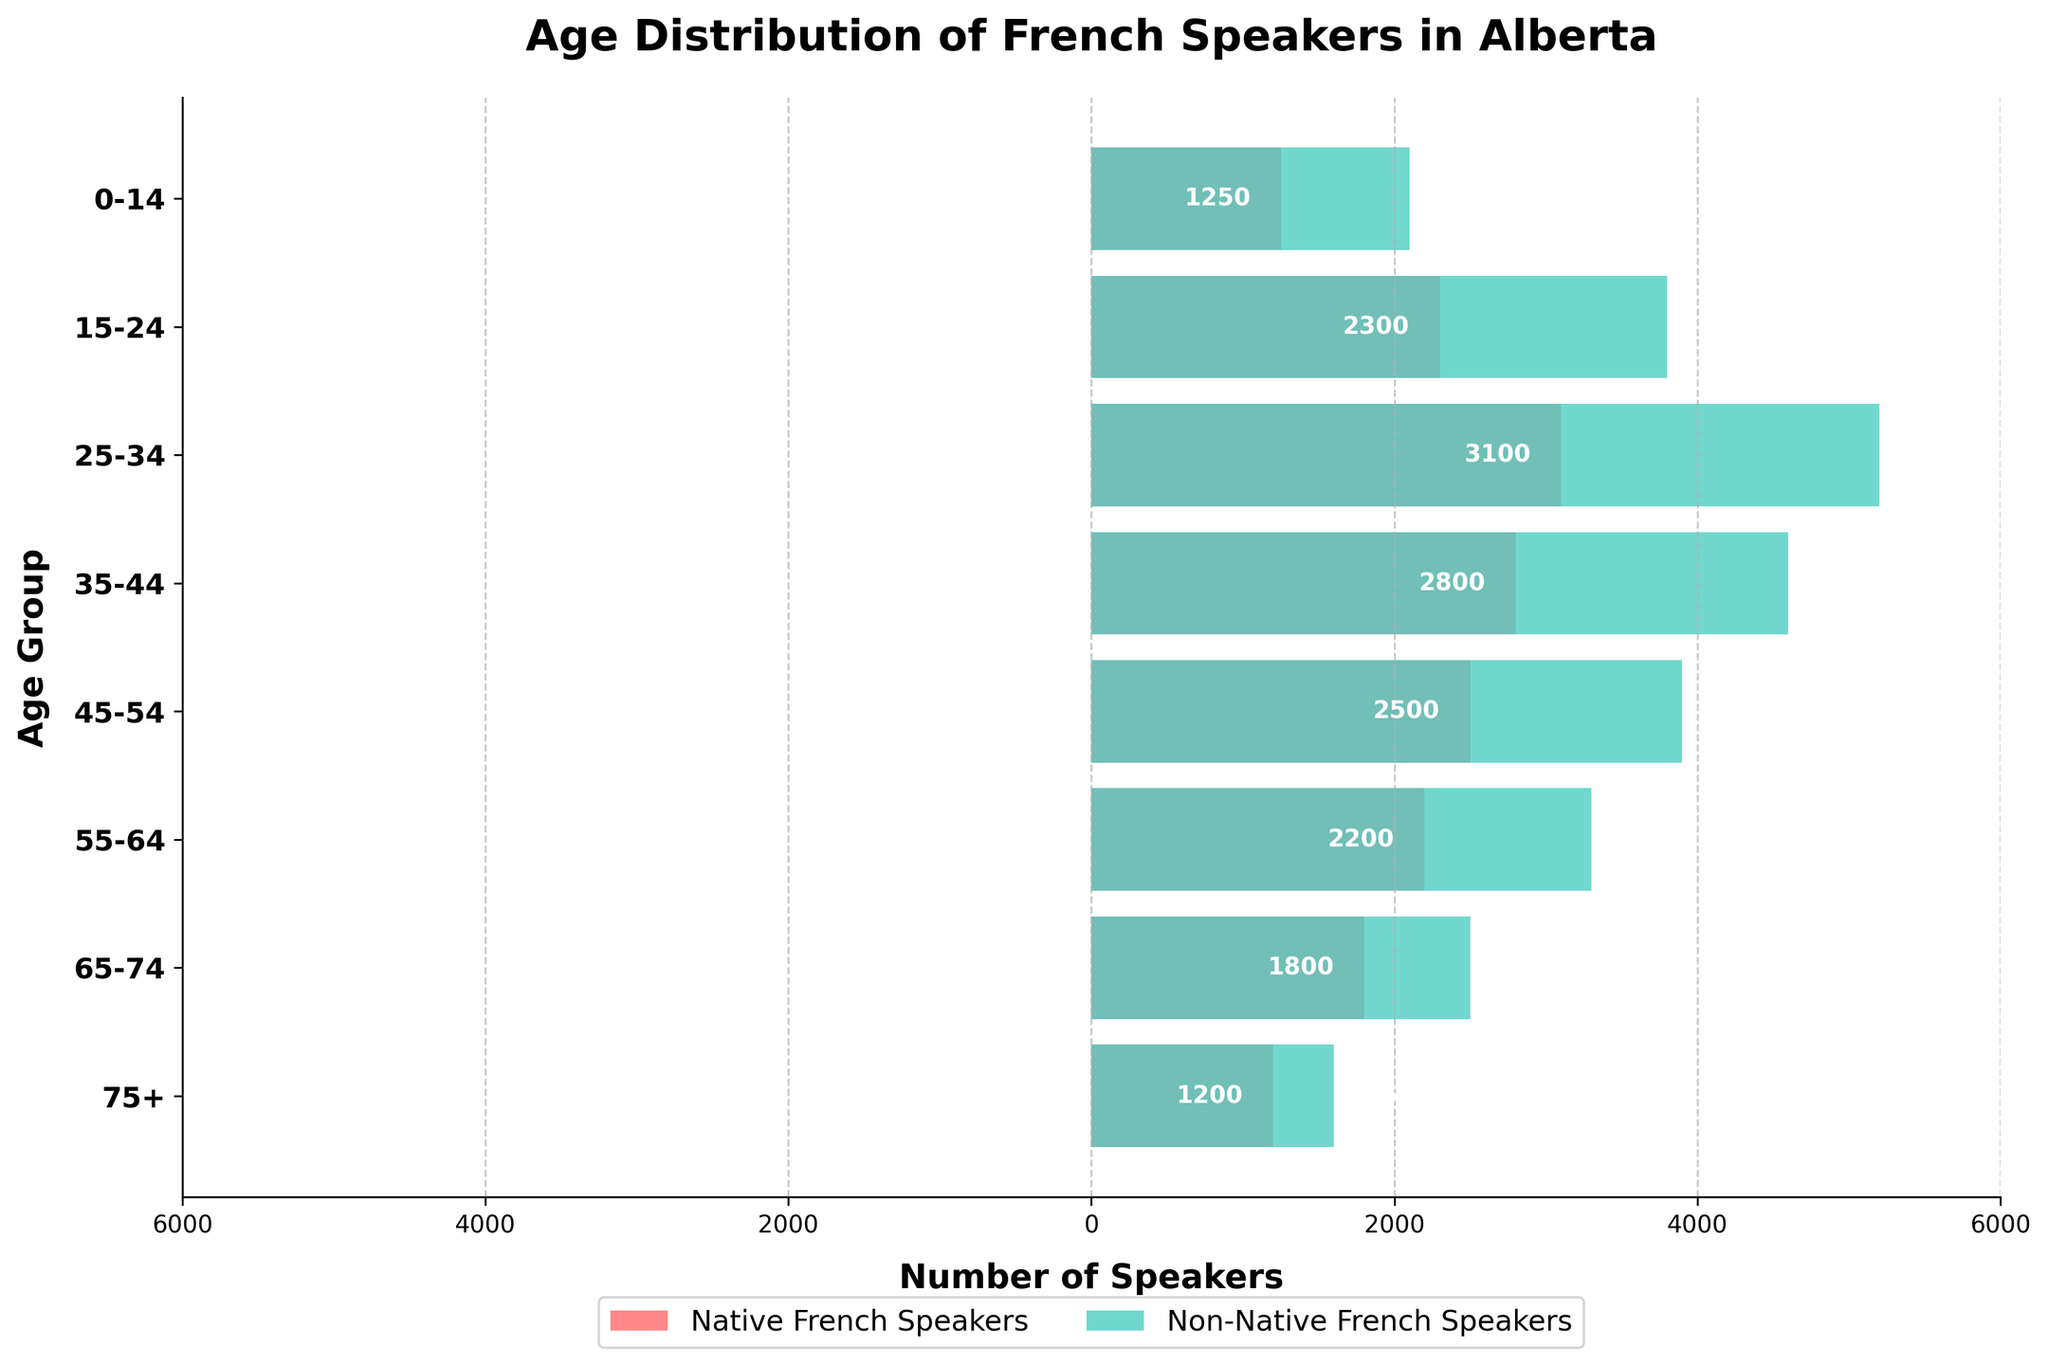What's the title of the figure? The title is displayed at the top of the figure, making it easy to identify without any deeper interpretation or analysis.
Answer: Age Distribution of French Speakers in Alberta Which age group has the highest number of non-native French speakers? The highest bar on the non-native French speakers' side represents the largest number, and it corresponds to the 25-34 age group.
Answer: 25-34 How many native French speakers are aged 0-14? Look at the value corresponding to the 0-14 age group on the native French speakers' side. The number (ignoring the negative sign) on that bar is 1250.
Answer: 1250 Compare the number of native and non-native French speakers aged 35-44. Which group has more speakers and by how many? The bar for native French speakers aged 35-44 indicates 2800, and the bar for non-native French speakers indicates 4600. Subtract the number of native speakers from non-native speakers: 4600 - 2800 = 1800.
Answer: Non-native by 1800 Consider the age group 55-64. What is the ratio of non-native French speakers to native French speakers? The number of non-native speakers in this group is 3300 and native speakers are 2200. The ratio is calculated as 3300 / 2200.
Answer: 1.5 Which age group has the smallest difference in the number of native and non-native French speakers, and what is that difference? Calculate the absolute difference for each age group and find the smallest. For example, 1200-2100, 2300-3800, etc. The smallest difference seems to be in the 75+ age group: 1600 - 1200 = 400.
Answer: 75+, Difference = 400 What percentage of non-native French speakers are aged 45-54 (compared to the total number of non-native speakers)? Sum all non-native speakers: 2100 + 3800 + 5200 + 4600 + 3900 + 3300 + 2500 + 1600 = 27000. For 45-54: (3900 / 27000) * 100%.
Answer: 14.44% How does the number of non-native French speakers aged 65-74 compare to the number of native French speakers aged 0-14? Compare the absolute values: 2500 (non-native aged 65-74) and 1250 (native aged 0-14). Non-native speakers aged 65-74 are exactly double the native speakers aged 0-14.
Answer: Double What is the trend in the number of native French speakers across different age groups? Observe the bars on the native French speakers' side. The number generally decreases as age increases, starting from the 25-34 age group.
Answer: Decreasing Considering all age groups, what is the total number of native and non-native French speakers combined? Add up all native and non-native values separately: Native: 1250 + 2300 + 3100 + 2800 + 2500 + 2200 + 1800 + 1200 = 17150; Non-native: 2100 + 3800 + 5200 + 4600 + 3900 + 3300 + 2500 + 1600 = 27000; Combined: 17150 + 27000 = 44150.
Answer: 44150 